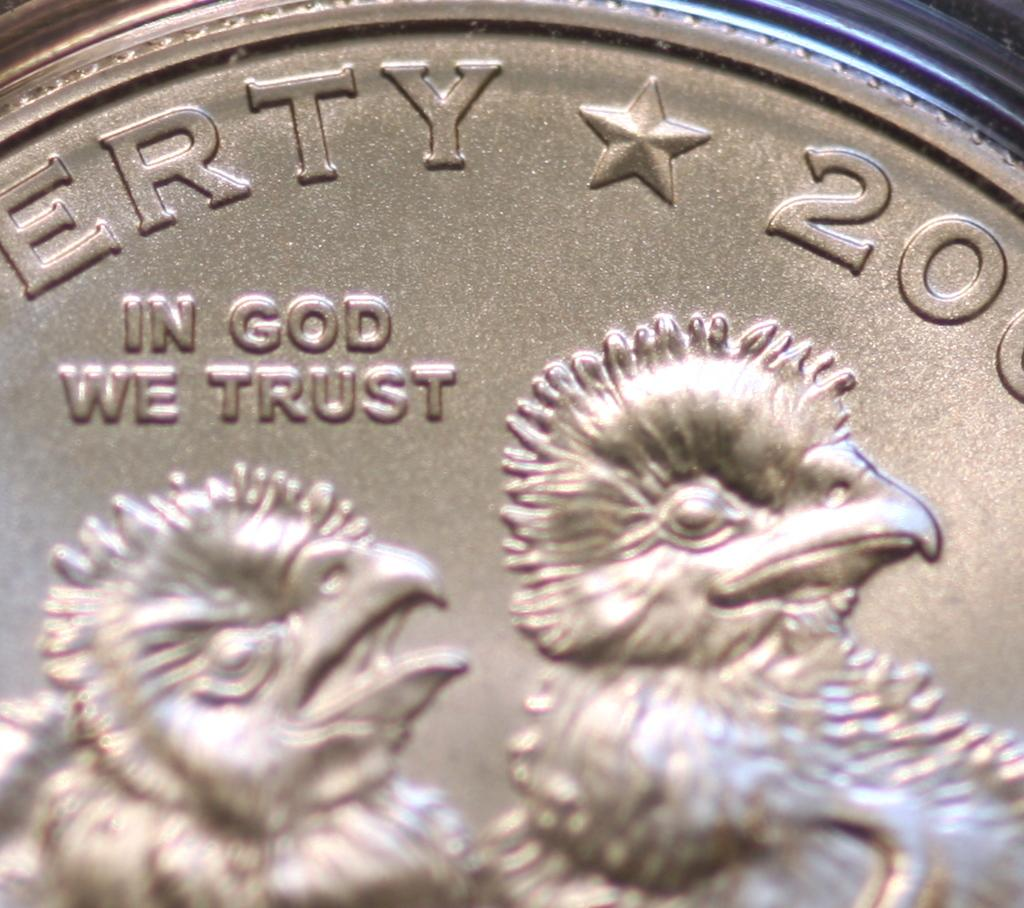<image>
Provide a brief description of the given image. The coin has the saying In God We Trust on it 